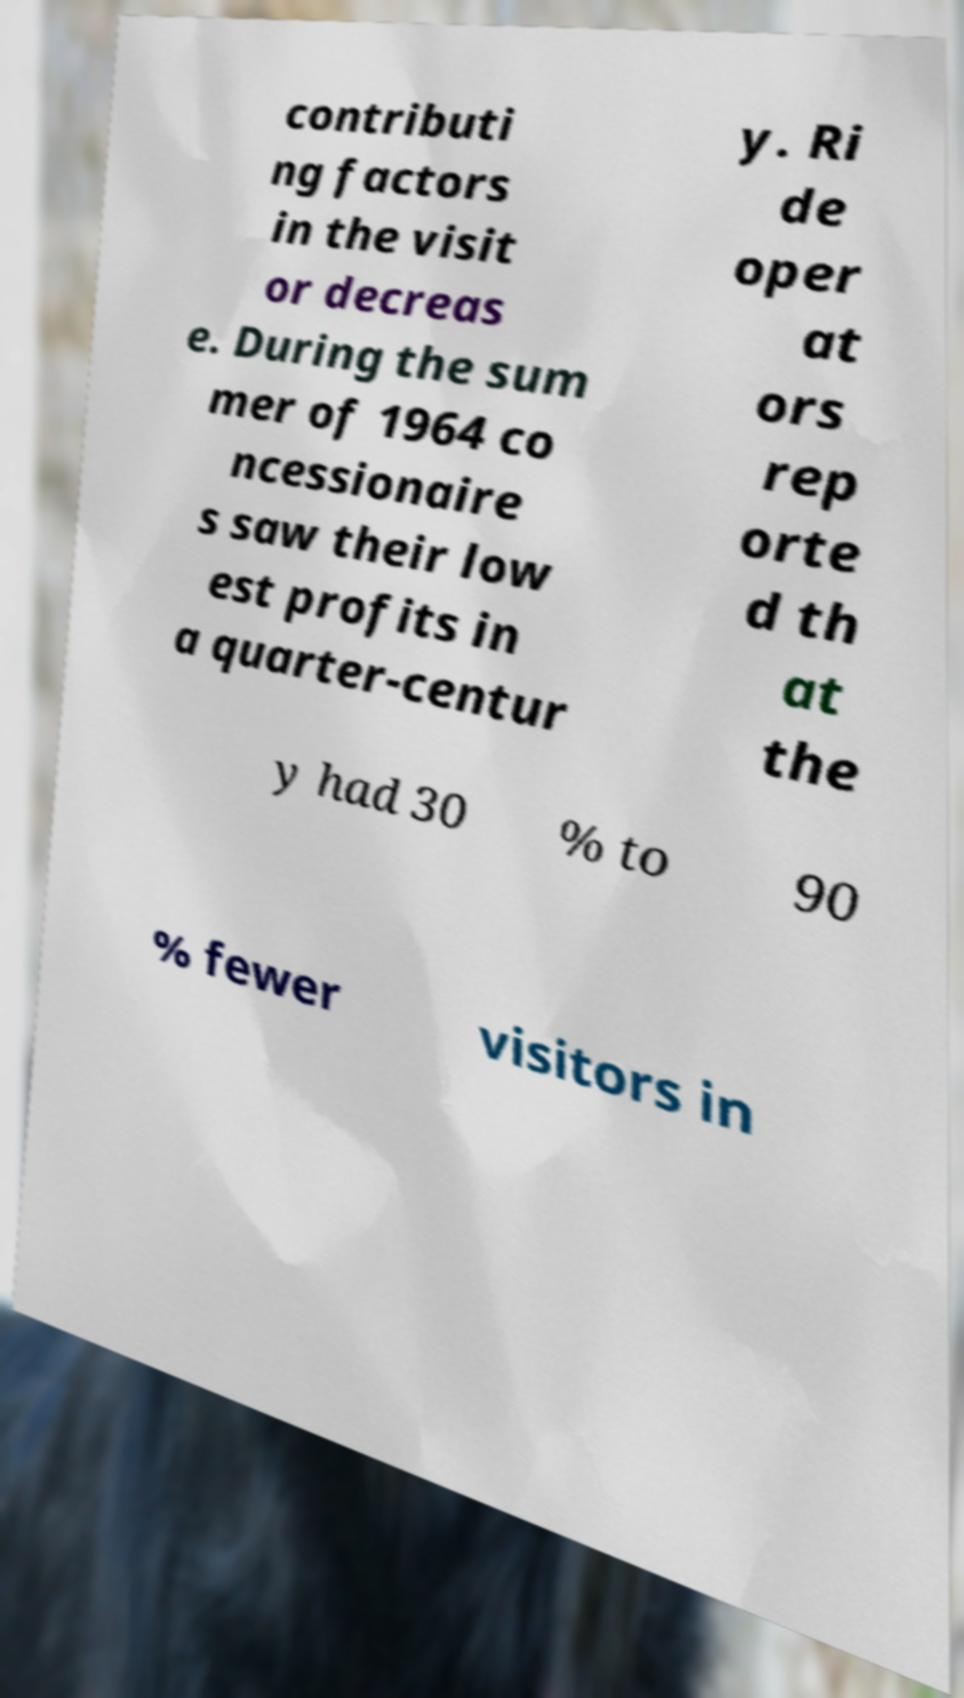Please identify and transcribe the text found in this image. contributi ng factors in the visit or decreas e. During the sum mer of 1964 co ncessionaire s saw their low est profits in a quarter-centur y. Ri de oper at ors rep orte d th at the y had 30 % to 90 % fewer visitors in 